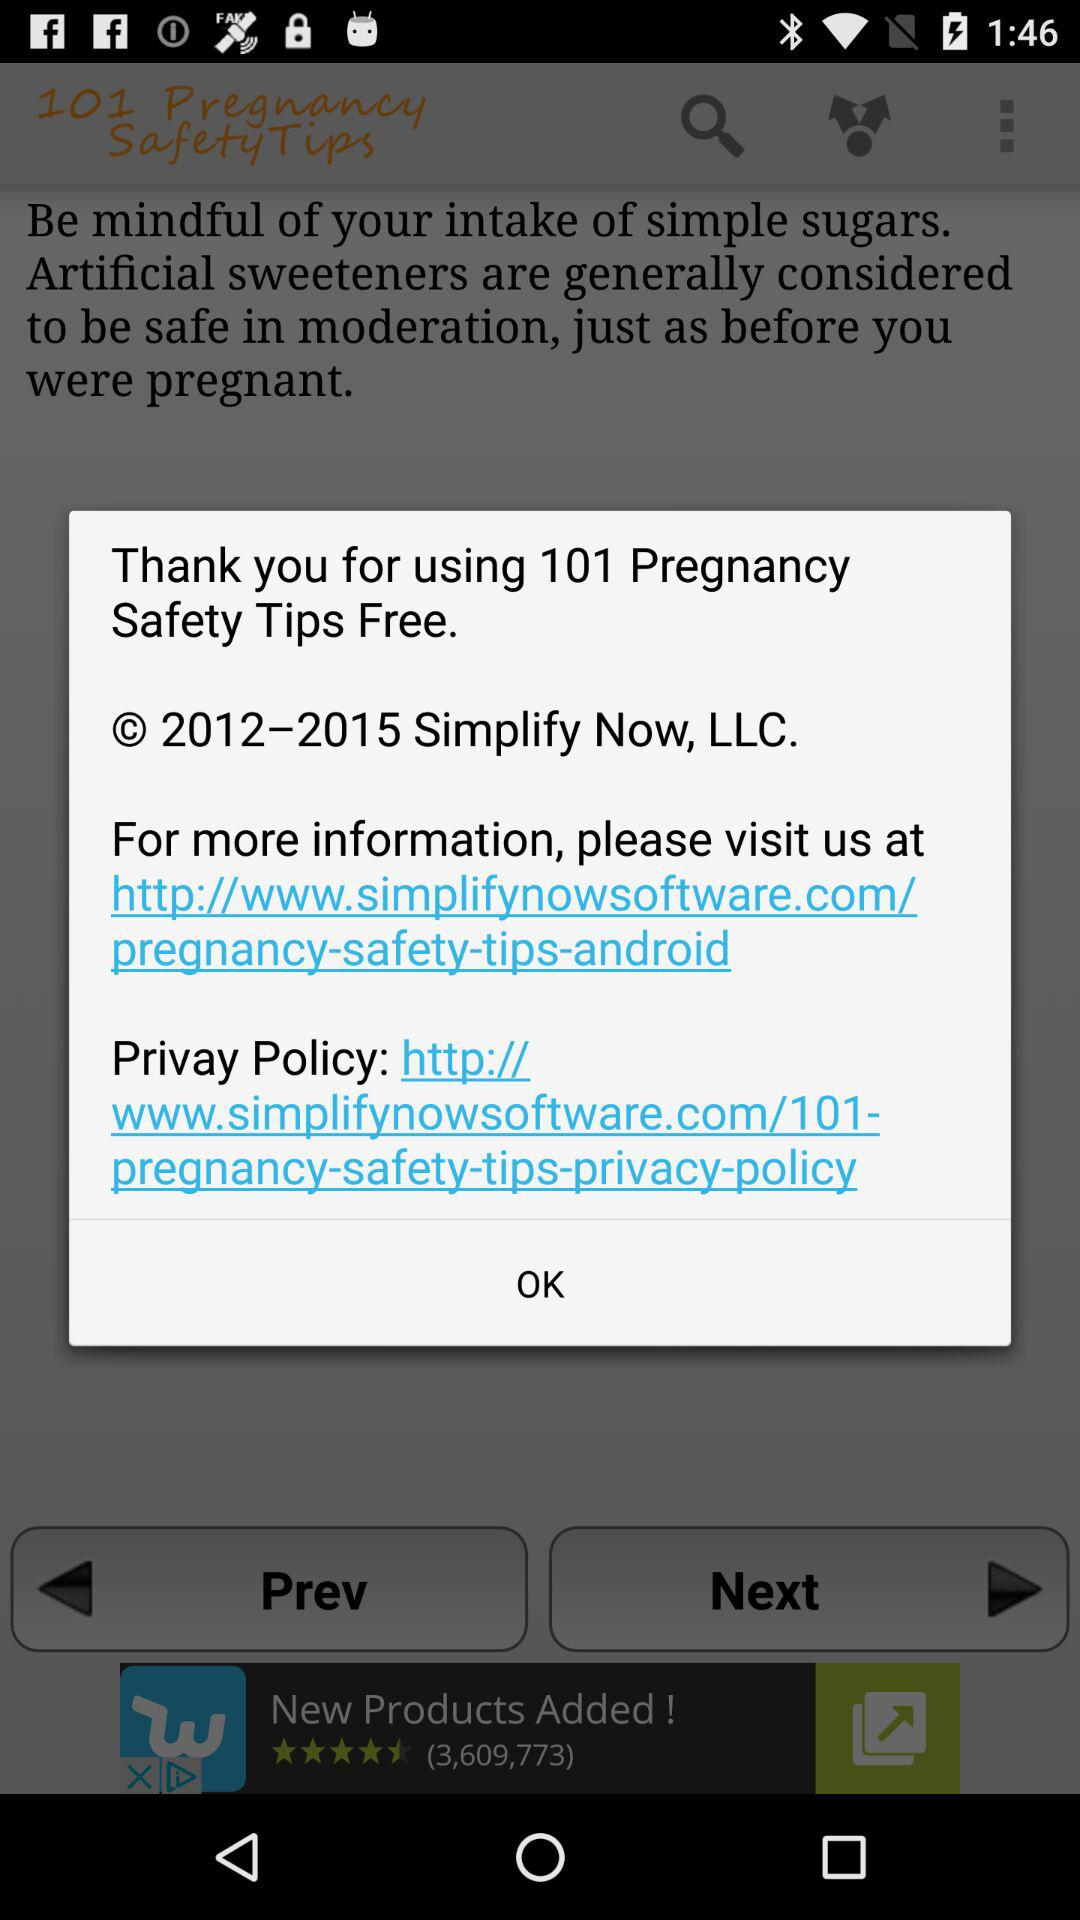How many links are there on this screen?
Answer the question using a single word or phrase. 2 